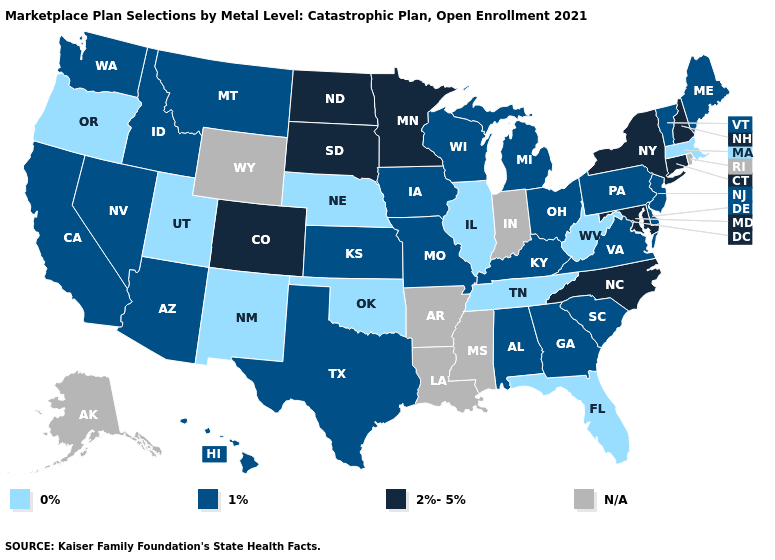Among the states that border Arizona , which have the highest value?
Concise answer only. Colorado. What is the value of South Carolina?
Write a very short answer. 1%. Which states have the lowest value in the West?
Write a very short answer. New Mexico, Oregon, Utah. What is the lowest value in the USA?
Short answer required. 0%. Which states hav the highest value in the South?
Quick response, please. Maryland, North Carolina. Does Arizona have the lowest value in the USA?
Quick response, please. No. Name the states that have a value in the range 0%?
Be succinct. Florida, Illinois, Massachusetts, Nebraska, New Mexico, Oklahoma, Oregon, Tennessee, Utah, West Virginia. What is the value of Delaware?
Answer briefly. 1%. What is the highest value in the MidWest ?
Short answer required. 2%-5%. Name the states that have a value in the range 2%-5%?
Keep it brief. Colorado, Connecticut, Maryland, Minnesota, New Hampshire, New York, North Carolina, North Dakota, South Dakota. Among the states that border Rhode Island , does Connecticut have the lowest value?
Quick response, please. No. Which states hav the highest value in the West?
Keep it brief. Colorado. Among the states that border Nevada , does Utah have the lowest value?
Give a very brief answer. Yes. Name the states that have a value in the range 0%?
Write a very short answer. Florida, Illinois, Massachusetts, Nebraska, New Mexico, Oklahoma, Oregon, Tennessee, Utah, West Virginia. How many symbols are there in the legend?
Concise answer only. 4. 